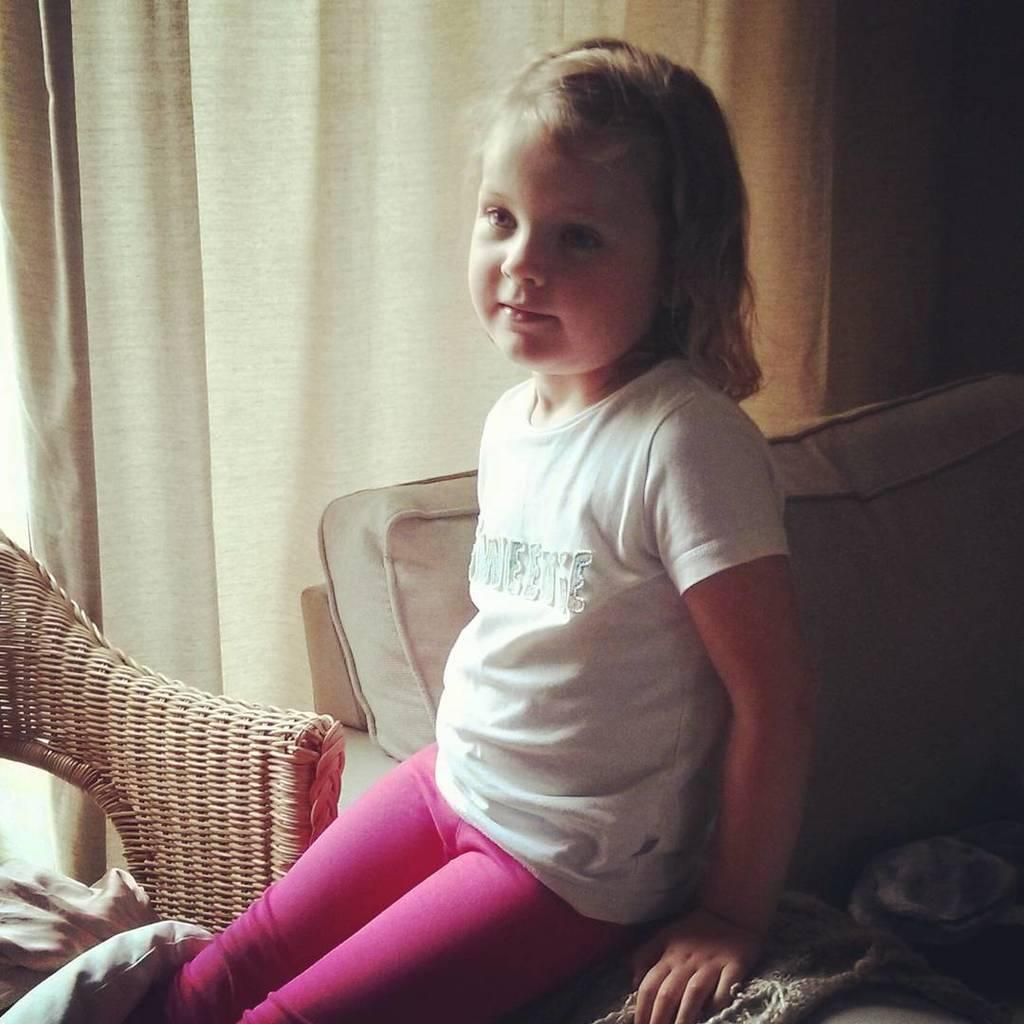Who is the main subject in the image? There is a girl in the image. What is the girl doing in the image? The girl is sitting. What is the girl wearing in the image? The girl is wearing a white top. What type of boat can be seen in the image? There is no boat present in the image; it features a girl sitting and wearing a white top. How many tomatoes are on the girl's plate in the image? There is no plate or tomatoes present in the image. 